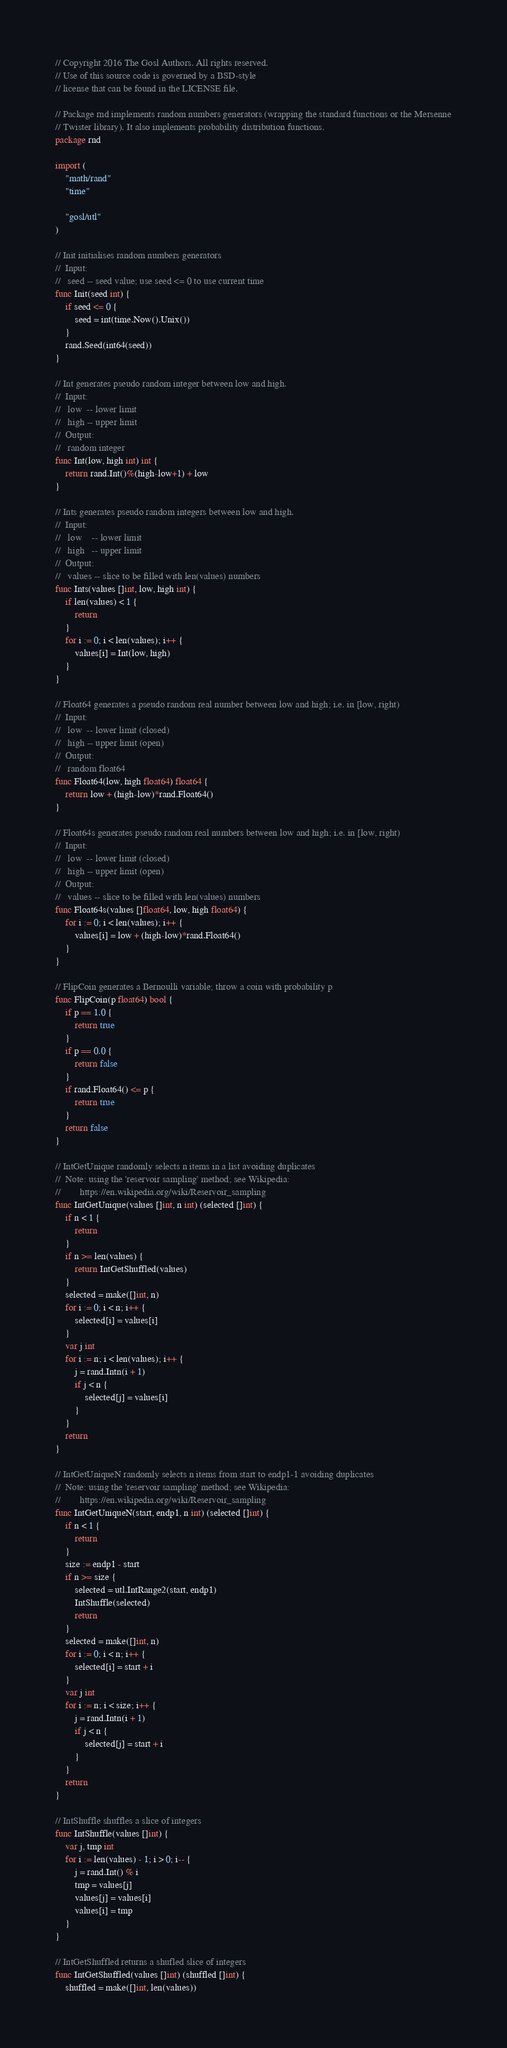Convert code to text. <code><loc_0><loc_0><loc_500><loc_500><_Go_>// Copyright 2016 The Gosl Authors. All rights reserved.
// Use of this source code is governed by a BSD-style
// license that can be found in the LICENSE file.

// Package rnd implements random numbers generators (wrapping the standard functions or the Mersenne
// Twister library). It also implements probability distribution functions.
package rnd

import (
	"math/rand"
	"time"

	"gosl/utl"
)

// Init initialises random numbers generators
//  Input:
//   seed -- seed value; use seed <= 0 to use current time
func Init(seed int) {
	if seed <= 0 {
		seed = int(time.Now().Unix())
	}
	rand.Seed(int64(seed))
}

// Int generates pseudo random integer between low and high.
//  Input:
//   low  -- lower limit
//   high -- upper limit
//  Output:
//   random integer
func Int(low, high int) int {
	return rand.Int()%(high-low+1) + low
}

// Ints generates pseudo random integers between low and high.
//  Input:
//   low    -- lower limit
//   high   -- upper limit
//  Output:
//   values -- slice to be filled with len(values) numbers
func Ints(values []int, low, high int) {
	if len(values) < 1 {
		return
	}
	for i := 0; i < len(values); i++ {
		values[i] = Int(low, high)
	}
}

// Float64 generates a pseudo random real number between low and high; i.e. in [low, right)
//  Input:
//   low  -- lower limit (closed)
//   high -- upper limit (open)
//  Output:
//   random float64
func Float64(low, high float64) float64 {
	return low + (high-low)*rand.Float64()
}

// Float64s generates pseudo random real numbers between low and high; i.e. in [low, right)
//  Input:
//   low  -- lower limit (closed)
//   high -- upper limit (open)
//  Output:
//   values -- slice to be filled with len(values) numbers
func Float64s(values []float64, low, high float64) {
	for i := 0; i < len(values); i++ {
		values[i] = low + (high-low)*rand.Float64()
	}
}

// FlipCoin generates a Bernoulli variable; throw a coin with probability p
func FlipCoin(p float64) bool {
	if p == 1.0 {
		return true
	}
	if p == 0.0 {
		return false
	}
	if rand.Float64() <= p {
		return true
	}
	return false
}

// IntGetUnique randomly selects n items in a list avoiding duplicates
//  Note: using the 'reservoir sampling' method; see Wikipedia:
//        https://en.wikipedia.org/wiki/Reservoir_sampling
func IntGetUnique(values []int, n int) (selected []int) {
	if n < 1 {
		return
	}
	if n >= len(values) {
		return IntGetShuffled(values)
	}
	selected = make([]int, n)
	for i := 0; i < n; i++ {
		selected[i] = values[i]
	}
	var j int
	for i := n; i < len(values); i++ {
		j = rand.Intn(i + 1)
		if j < n {
			selected[j] = values[i]
		}
	}
	return
}

// IntGetUniqueN randomly selects n items from start to endp1-1 avoiding duplicates
//  Note: using the 'reservoir sampling' method; see Wikipedia:
//        https://en.wikipedia.org/wiki/Reservoir_sampling
func IntGetUniqueN(start, endp1, n int) (selected []int) {
	if n < 1 {
		return
	}
	size := endp1 - start
	if n >= size {
		selected = utl.IntRange2(start, endp1)
		IntShuffle(selected)
		return
	}
	selected = make([]int, n)
	for i := 0; i < n; i++ {
		selected[i] = start + i
	}
	var j int
	for i := n; i < size; i++ {
		j = rand.Intn(i + 1)
		if j < n {
			selected[j] = start + i
		}
	}
	return
}

// IntShuffle shuffles a slice of integers
func IntShuffle(values []int) {
	var j, tmp int
	for i := len(values) - 1; i > 0; i-- {
		j = rand.Int() % i
		tmp = values[j]
		values[j] = values[i]
		values[i] = tmp
	}
}

// IntGetShuffled returns a shufled slice of integers
func IntGetShuffled(values []int) (shuffled []int) {
	shuffled = make([]int, len(values))</code> 